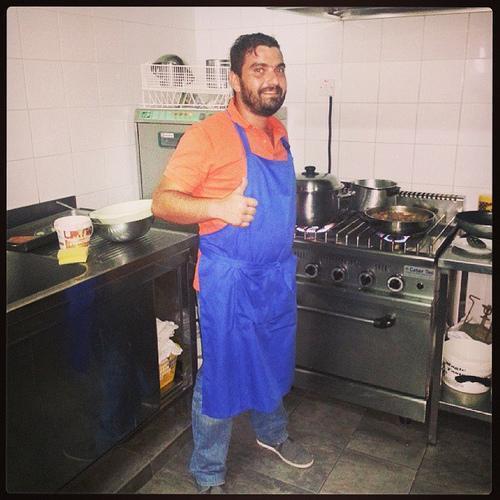How many people are pictured?
Give a very brief answer. 1. 